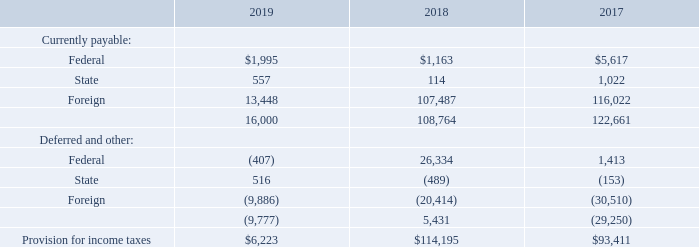16. INCOME TAXES
The provision for (benefit from) income taxes on income from continuing operations before income taxes consists of the following (in thousands):
What was the Provision for income taxes in 2019?
Answer scale should be: thousand. $6,223. What was the currently payable federal income tax in 2019?
Answer scale should be: thousand. $1,995. In which years was provision for income taxes calculated? 2019, 2018, 2017. In which year was Provision for income taxes largest? 114,195>93,411>6,223
Answer: 2018. What was the change in state income taxes that is currently payable in 2019 from 2018?
Answer scale should be: thousand. 557-114
Answer: 443. What was the percentage change in state income taxes that is currently payable in 2019 from 2018?
Answer scale should be: percent. (557-114)/114
Answer: 388.6. 